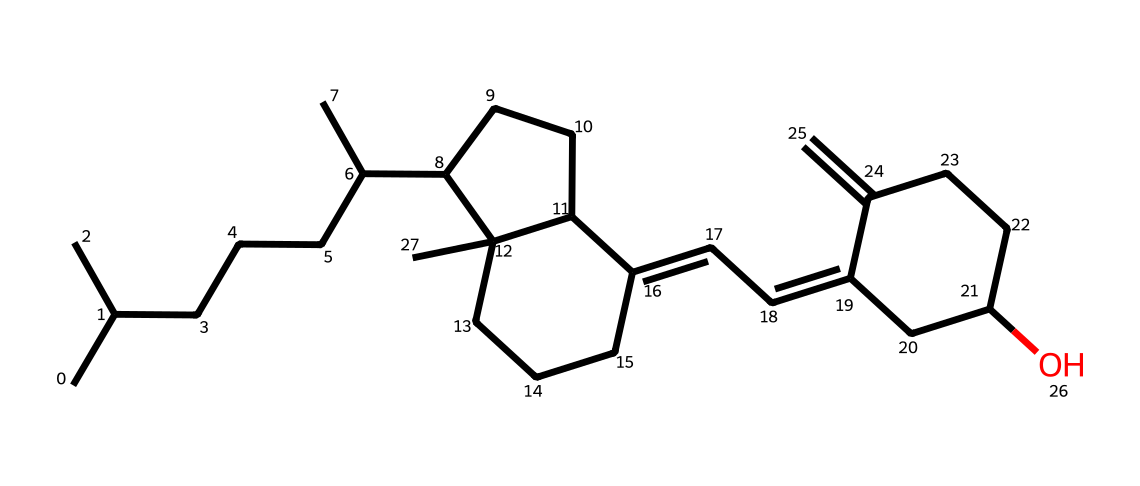what is the molecular formula of this vitamin D structure? By analyzing the molecular structure derived from the SMILES representation, we can count the number of carbon (C), hydrogen (H), and oxygen (O) atoms present. The breakdown shows that there are 27 carbon atoms, 46 hydrogen atoms, and 1 oxygen atom, leading to the formula C27H46O.
Answer: C27H46O how many rings are present in this chemical structure? By examining the structure visually or interpreting the SMILES representation, we can identify closed loops in the molecular formation. The chemical contains a total of 3 rings.
Answer: 3 does this chemical contain any functional groups? The functional groups are characterized by specific atoms or arrangements of atoms. In the provided structure, we can observe the presence of a hydroxyl group (-OH) which indicates it's a steroid structure commonly associated with vitamin D.
Answer: yes what role does this vitamin D structure play in calcium absorption? This structure is essential in the body's regulation of calcium and phosphate metabolism. Vitamin D promotes the intestinal absorption of calcium, enhancing bone mineralization.
Answer: enhances absorption what is the impact of vitamin D deficiency on calcium levels? When there is a deficiency of vitamin D, the body cannot absorb calcium effectively from the diet, which can lead to decreased calcium levels in the blood and potential bone disorders.
Answer: decreases calcium levels how does the structure of vitamin D facilitate its biological function? The multi-ring and hydrocarbon structure of vitamin D allows it to efficiently interact with vitamin D receptors in the intestines, promoting the absorption of calcium and phosphate and maintaining bone health.
Answer: promotes interaction with receptors 